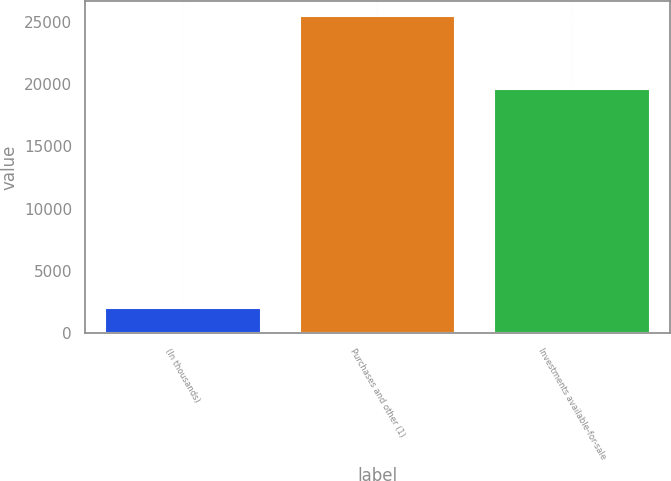<chart> <loc_0><loc_0><loc_500><loc_500><bar_chart><fcel>(In thousands)<fcel>Purchases and other (1)<fcel>Investments available-for-sale<nl><fcel>2012<fcel>25419<fcel>19591<nl></chart> 